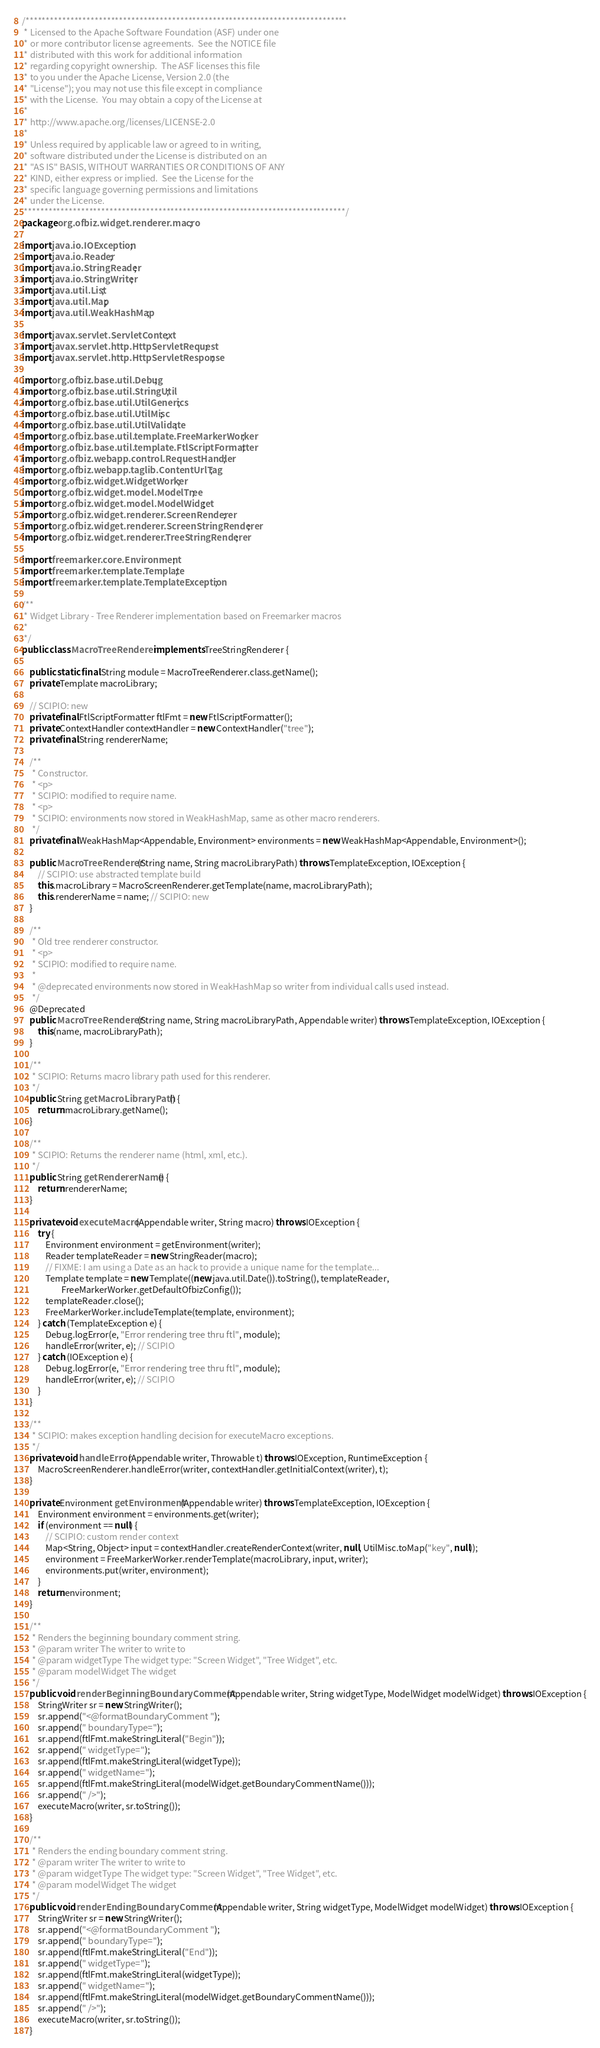<code> <loc_0><loc_0><loc_500><loc_500><_Java_>/*******************************************************************************
 * Licensed to the Apache Software Foundation (ASF) under one
 * or more contributor license agreements.  See the NOTICE file
 * distributed with this work for additional information
 * regarding copyright ownership.  The ASF licenses this file
 * to you under the Apache License, Version 2.0 (the
 * "License"); you may not use this file except in compliance
 * with the License.  You may obtain a copy of the License at
 *
 * http://www.apache.org/licenses/LICENSE-2.0
 *
 * Unless required by applicable law or agreed to in writing,
 * software distributed under the License is distributed on an
 * "AS IS" BASIS, WITHOUT WARRANTIES OR CONDITIONS OF ANY
 * KIND, either express or implied.  See the License for the
 * specific language governing permissions and limitations
 * under the License.
 *******************************************************************************/
package org.ofbiz.widget.renderer.macro;

import java.io.IOException;
import java.io.Reader;
import java.io.StringReader;
import java.io.StringWriter;
import java.util.List;
import java.util.Map;
import java.util.WeakHashMap;

import javax.servlet.ServletContext;
import javax.servlet.http.HttpServletRequest;
import javax.servlet.http.HttpServletResponse;

import org.ofbiz.base.util.Debug;
import org.ofbiz.base.util.StringUtil;
import org.ofbiz.base.util.UtilGenerics;
import org.ofbiz.base.util.UtilMisc;
import org.ofbiz.base.util.UtilValidate;
import org.ofbiz.base.util.template.FreeMarkerWorker;
import org.ofbiz.base.util.template.FtlScriptFormatter;
import org.ofbiz.webapp.control.RequestHandler;
import org.ofbiz.webapp.taglib.ContentUrlTag;
import org.ofbiz.widget.WidgetWorker;
import org.ofbiz.widget.model.ModelTree;
import org.ofbiz.widget.model.ModelWidget;
import org.ofbiz.widget.renderer.ScreenRenderer;
import org.ofbiz.widget.renderer.ScreenStringRenderer;
import org.ofbiz.widget.renderer.TreeStringRenderer;

import freemarker.core.Environment;
import freemarker.template.Template;
import freemarker.template.TemplateException;

/**
 * Widget Library - Tree Renderer implementation based on Freemarker macros
 * 
 */
public class MacroTreeRenderer implements TreeStringRenderer {

    public static final String module = MacroTreeRenderer.class.getName();
    private Template macroLibrary;
    
    // SCIPIO: new
    private final FtlScriptFormatter ftlFmt = new FtlScriptFormatter();
    private ContextHandler contextHandler = new ContextHandler("tree");
    private final String rendererName;
    
    /**
     * Constructor.
     * <p>
     * SCIPIO: modified to require name.
     * <p>
     * SCIPIO: environments now stored in WeakHashMap, same as other macro renderers.
     */
    private final WeakHashMap<Appendable, Environment> environments = new WeakHashMap<Appendable, Environment>();

    public MacroTreeRenderer(String name, String macroLibraryPath) throws TemplateException, IOException {
        // SCIPIO: use abstracted template build
        this.macroLibrary = MacroScreenRenderer.getTemplate(name, macroLibraryPath);
        this.rendererName = name; // SCIPIO: new
    }
    
    /**
     * Old tree renderer constructor.
     * <p>
     * SCIPIO: modified to require name.
     * 
     * @deprecated environments now stored in WeakHashMap so writer from individual calls used instead.
     */
    @Deprecated
    public MacroTreeRenderer(String name, String macroLibraryPath, Appendable writer) throws TemplateException, IOException {
        this(name, macroLibraryPath);
    }
    
    /**
     * SCIPIO: Returns macro library path used for this renderer. 
     */
    public String getMacroLibraryPath() {
        return macroLibrary.getName();
    }
    
    /**
     * SCIPIO: Returns the renderer name (html, xml, etc.).
     */
    public String getRendererName() {
        return rendererName;
    }
    
    private void executeMacro(Appendable writer, String macro) throws IOException {
        try {
            Environment environment = getEnvironment(writer);
            Reader templateReader = new StringReader(macro);
            // FIXME: I am using a Date as an hack to provide a unique name for the template...
            Template template = new Template((new java.util.Date()).toString(), templateReader,
                    FreeMarkerWorker.getDefaultOfbizConfig());
            templateReader.close();
            FreeMarkerWorker.includeTemplate(template, environment);
        } catch (TemplateException e) {
            Debug.logError(e, "Error rendering tree thru ftl", module);
            handleError(writer, e); // SCIPIO
        } catch (IOException e) {
            Debug.logError(e, "Error rendering tree thru ftl", module);
            handleError(writer, e); // SCIPIO
        }
    }
 
    /**
     * SCIPIO: makes exception handling decision for executeMacro exceptions.
     */
    private void handleError(Appendable writer, Throwable t) throws IOException, RuntimeException {
        MacroScreenRenderer.handleError(writer, contextHandler.getInitialContext(writer), t);
    }
    
    private Environment getEnvironment(Appendable writer) throws TemplateException, IOException {
        Environment environment = environments.get(writer);
        if (environment == null) {
            // SCIPIO: custom render context
            Map<String, Object> input = contextHandler.createRenderContext(writer, null, UtilMisc.toMap("key", null));
            environment = FreeMarkerWorker.renderTemplate(macroLibrary, input, writer);
            environments.put(writer, environment);
        }
        return environment;
    }
    
    /**
     * Renders the beginning boundary comment string.
     * @param writer The writer to write to
     * @param widgetType The widget type: "Screen Widget", "Tree Widget", etc.
     * @param modelWidget The widget
     */
    public void renderBeginningBoundaryComment(Appendable writer, String widgetType, ModelWidget modelWidget) throws IOException {
        StringWriter sr = new StringWriter();
        sr.append("<@formatBoundaryComment ");
        sr.append(" boundaryType=");
        sr.append(ftlFmt.makeStringLiteral("Begin"));
        sr.append(" widgetType=");
        sr.append(ftlFmt.makeStringLiteral(widgetType));
        sr.append(" widgetName=");
        sr.append(ftlFmt.makeStringLiteral(modelWidget.getBoundaryCommentName()));
        sr.append(" />");
        executeMacro(writer, sr.toString());
    }
    
    /**
     * Renders the ending boundary comment string.
     * @param writer The writer to write to
     * @param widgetType The widget type: "Screen Widget", "Tree Widget", etc.
     * @param modelWidget The widget
     */
    public void renderEndingBoundaryComment(Appendable writer, String widgetType, ModelWidget modelWidget) throws IOException {
        StringWriter sr = new StringWriter();
        sr.append("<@formatBoundaryComment ");
        sr.append(" boundaryType=");
        sr.append(ftlFmt.makeStringLiteral("End"));
        sr.append(" widgetType=");
        sr.append(ftlFmt.makeStringLiteral(widgetType));
        sr.append(" widgetName=");
        sr.append(ftlFmt.makeStringLiteral(modelWidget.getBoundaryCommentName()));
        sr.append(" />");
        executeMacro(writer, sr.toString());
    }</code> 